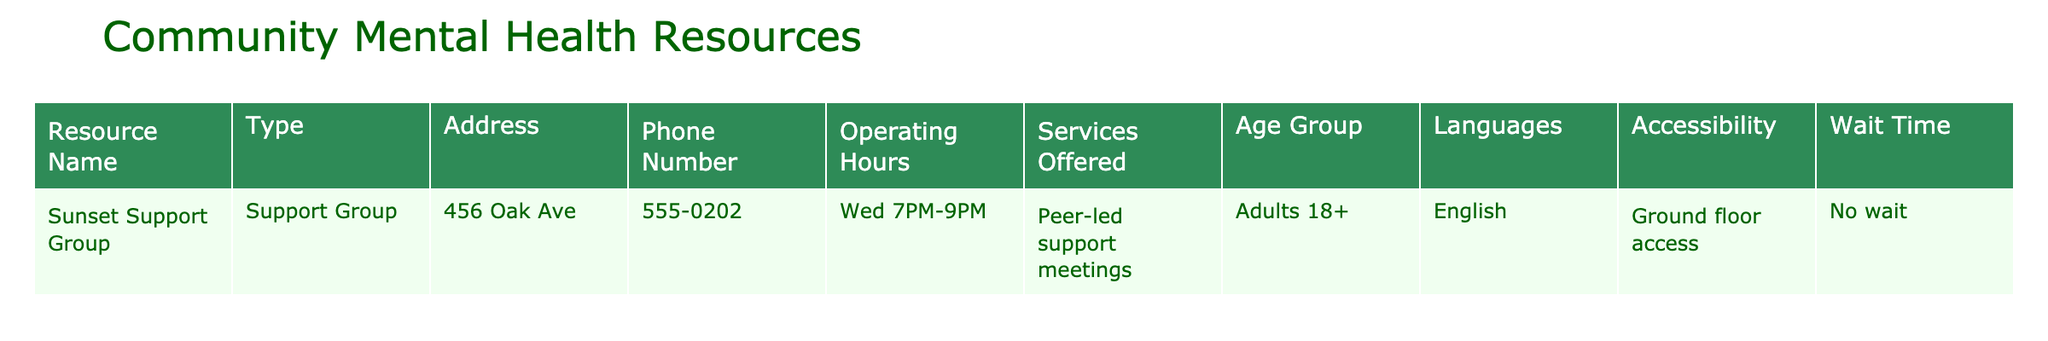What is the address of the Sunset Support Group? The address is listed directly in the table under the "Address" column next to the resource name. It states "456 Oak Ave."
Answer: 456 Oak Ave What are the operating hours of the Sunset Support Group? The operating hours can be found in the "Operating Hours" column for the Sunset Support Group, which specifies "Wed 7PM-9PM."
Answer: Wed 7PM-9PM Is the Sunset Support Group accessible for individuals with mobility issues? To find this, we look at the "Accessibility" column for the Sunset Support Group, which indicates "Ground floor access," implying it is accessible.
Answer: Yes How many age groups does the Sunset Support Group cater to? The "Age Group" column states that the resource is for "Adults 18+," indicating it serves one age group.
Answer: 1 What services are offered by the Sunset Support Group? The "Services Offered" column details that the Sunset Support Group provides "Peer-led support meetings." This can be directly referenced from the table.
Answer: Peer-led support meetings Which language is primarily used at the Sunset Support Group? The "Languages" column indicates that the primary language offered is "English," which is specific to the service provided.
Answer: English Is there a wait time for the Sunset Support Group? The "Wait Time" column specifies that there is "No wait," indicating that participants can access the service immediately.
Answer: No wait What type of resource is the Sunset Support Group? The "Type" column describes it as a "Support Group," which is a specific classification of the service offered.
Answer: Support Group Considering the accessibility of the Sunset Support Group, what might be important for someone with mobility issues? Since "Ground floor access" is specified, it is likely important for someone with mobility issues to know that the facility has no stairs, allowing easier access.
Answer: Ground floor access is important If a person wanted to attend the Sunset Support Group weekly, how often would they go? Since the operating hours indicate that it occurs on "Wed 7PM-9PM," a person could attend once a week, specifically every Wednesday.
Answer: Once a week Does the Sunset Support Group serve any age group below 18? The "Age Group" column specifies "Adults 18+," which means it does not serve anyone below this age bracket.
Answer: No What might be one benefit of joining a peer-led support group? While the table does not explicitly state benefits, support groups generally provide emotional support and shared experiences among peers, which is likely a key advantage.
Answer: Emotional support and shared experiences 